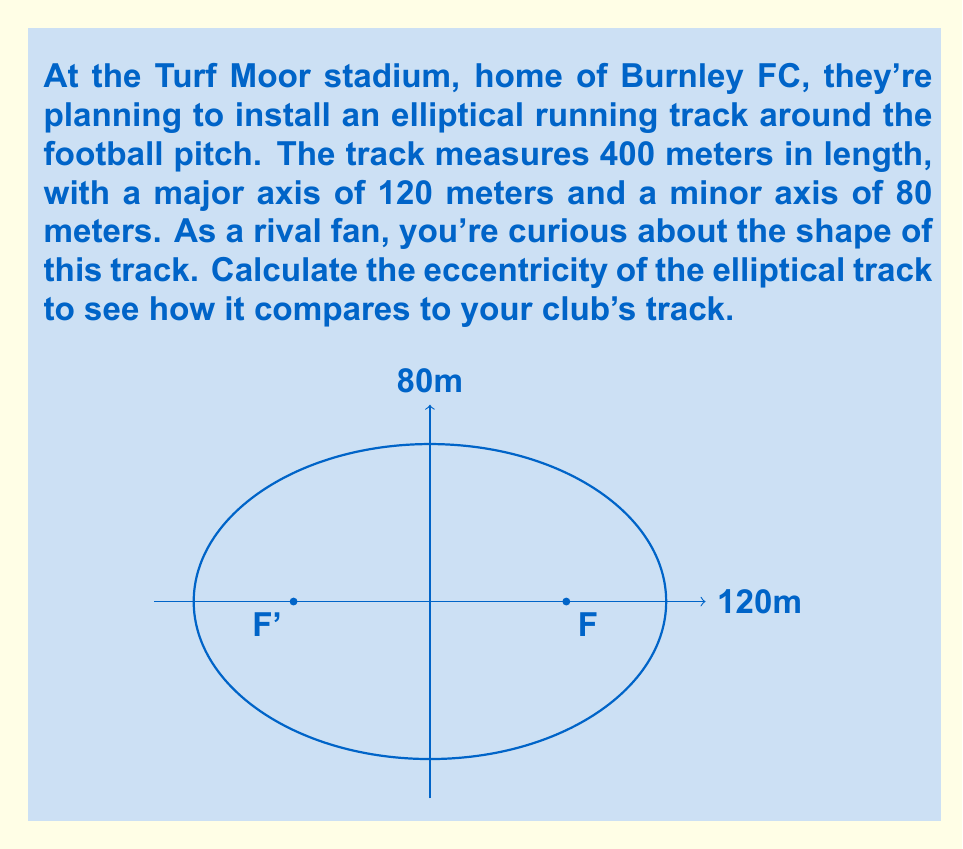Can you solve this math problem? Let's approach this step-by-step:

1) The eccentricity of an ellipse is defined as:

   $$e = \frac{c}{a}$$

   where $c$ is the distance from the center to a focus, and $a$ is the length of the semi-major axis.

2) We're given the length of the major axis (2a) and minor axis (2b):
   
   $2a = 120$ m, so $a = 60$ m
   $2b = 80$ m, so $b = 40$ m

3) To find $c$, we can use the Pythagorean theorem for ellipses:

   $$a^2 = b^2 + c^2$$

4) Rearranging to solve for $c$:

   $$c^2 = a^2 - b^2$$
   $$c = \sqrt{a^2 - b^2}$$

5) Substituting our values:

   $$c = \sqrt{60^2 - 40^2} = \sqrt{3600 - 1600} = \sqrt{2000} = 20\sqrt{5}$$

6) Now we can calculate the eccentricity:

   $$e = \frac{c}{a} = \frac{20\sqrt{5}}{60} = \frac{\sqrt{5}}{3}$$

7) This can be left as a fraction or converted to a decimal:

   $$\frac{\sqrt{5}}{3} \approx 0.745$$
Answer: $e = \frac{\sqrt{5}}{3} \approx 0.745$ 